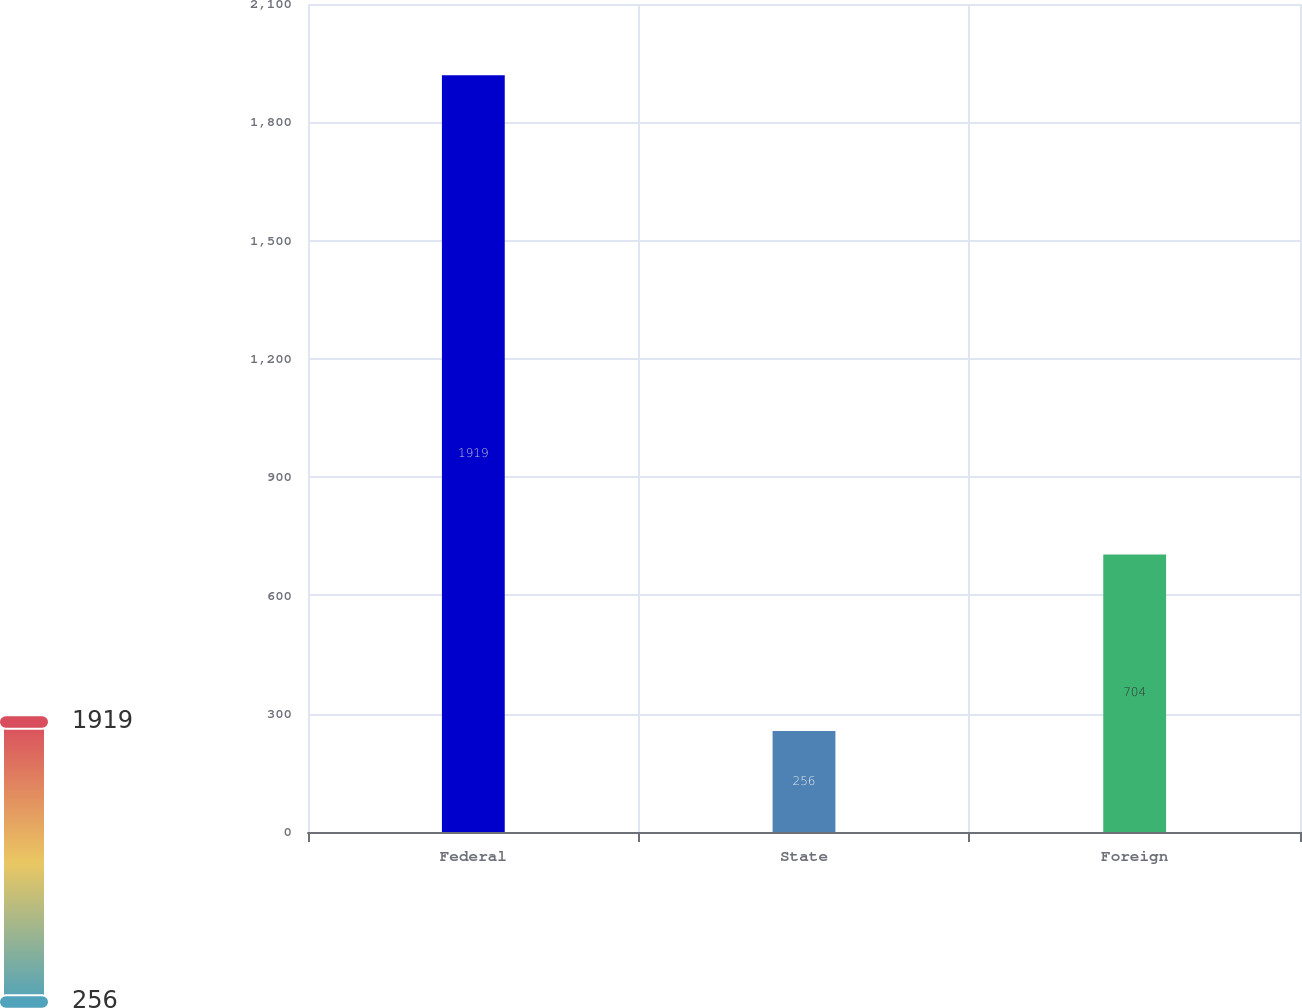Convert chart to OTSL. <chart><loc_0><loc_0><loc_500><loc_500><bar_chart><fcel>Federal<fcel>State<fcel>Foreign<nl><fcel>1919<fcel>256<fcel>704<nl></chart> 